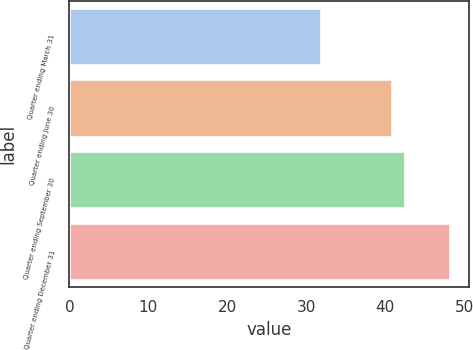<chart> <loc_0><loc_0><loc_500><loc_500><bar_chart><fcel>Quarter ending March 31<fcel>Quarter ending June 30<fcel>Quarter ending September 30<fcel>Quarter ending December 31<nl><fcel>31.84<fcel>40.82<fcel>42.45<fcel>48.18<nl></chart> 